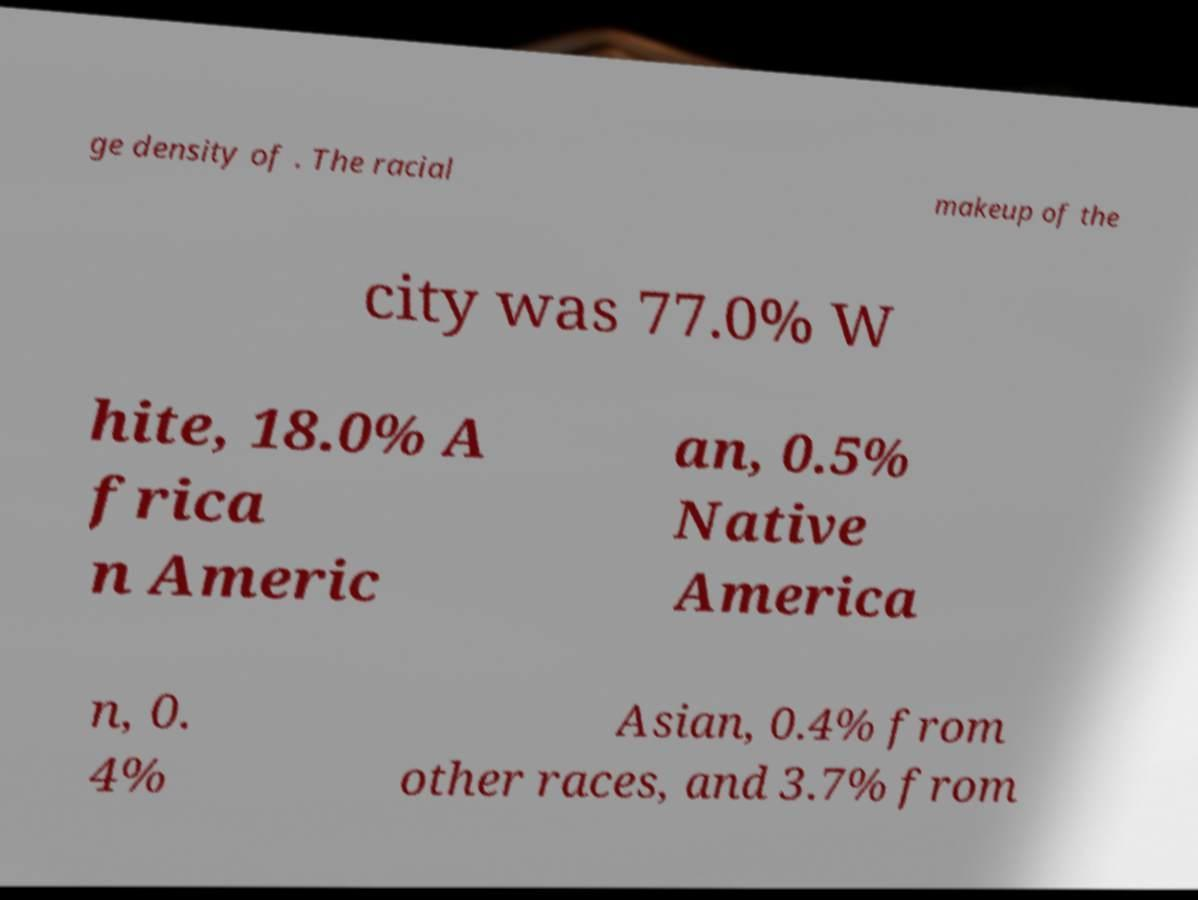Can you read and provide the text displayed in the image?This photo seems to have some interesting text. Can you extract and type it out for me? ge density of . The racial makeup of the city was 77.0% W hite, 18.0% A frica n Americ an, 0.5% Native America n, 0. 4% Asian, 0.4% from other races, and 3.7% from 